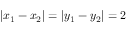<formula> <loc_0><loc_0><loc_500><loc_500>| x _ { 1 } - x _ { 2 } | = | y _ { 1 } - y _ { 2 } | = 2</formula> 